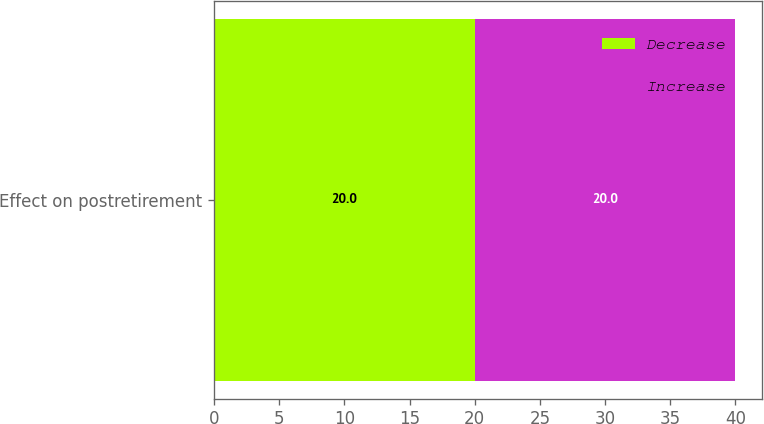<chart> <loc_0><loc_0><loc_500><loc_500><stacked_bar_chart><ecel><fcel>Effect on postretirement<nl><fcel>Decrease<fcel>20<nl><fcel>Increase<fcel>20<nl></chart> 